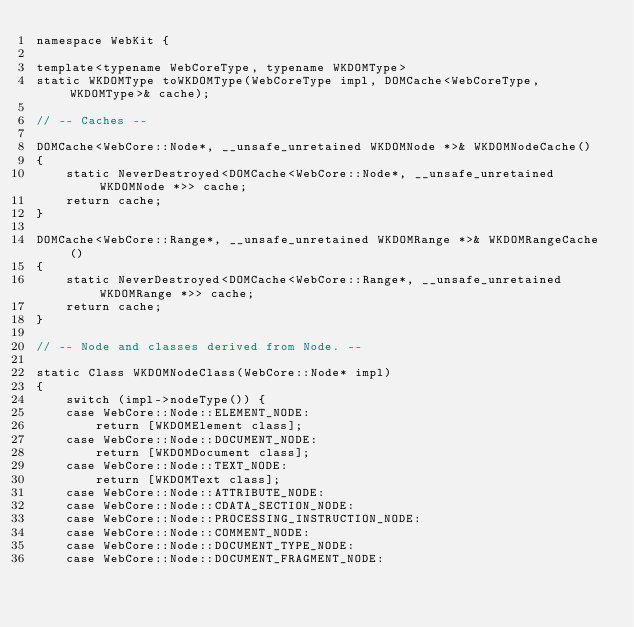<code> <loc_0><loc_0><loc_500><loc_500><_ObjectiveC_>namespace WebKit {

template<typename WebCoreType, typename WKDOMType>
static WKDOMType toWKDOMType(WebCoreType impl, DOMCache<WebCoreType, WKDOMType>& cache);

// -- Caches -- 

DOMCache<WebCore::Node*, __unsafe_unretained WKDOMNode *>& WKDOMNodeCache()
{
    static NeverDestroyed<DOMCache<WebCore::Node*, __unsafe_unretained WKDOMNode *>> cache;
    return cache;
}

DOMCache<WebCore::Range*, __unsafe_unretained WKDOMRange *>& WKDOMRangeCache()
{
    static NeverDestroyed<DOMCache<WebCore::Range*, __unsafe_unretained WKDOMRange *>> cache;
    return cache;
}

// -- Node and classes derived from Node. --

static Class WKDOMNodeClass(WebCore::Node* impl)
{
    switch (impl->nodeType()) {
    case WebCore::Node::ELEMENT_NODE:
        return [WKDOMElement class];
    case WebCore::Node::DOCUMENT_NODE:
        return [WKDOMDocument class];
    case WebCore::Node::TEXT_NODE:
        return [WKDOMText class];
    case WebCore::Node::ATTRIBUTE_NODE:
    case WebCore::Node::CDATA_SECTION_NODE:
    case WebCore::Node::PROCESSING_INSTRUCTION_NODE:
    case WebCore::Node::COMMENT_NODE:
    case WebCore::Node::DOCUMENT_TYPE_NODE:
    case WebCore::Node::DOCUMENT_FRAGMENT_NODE:</code> 